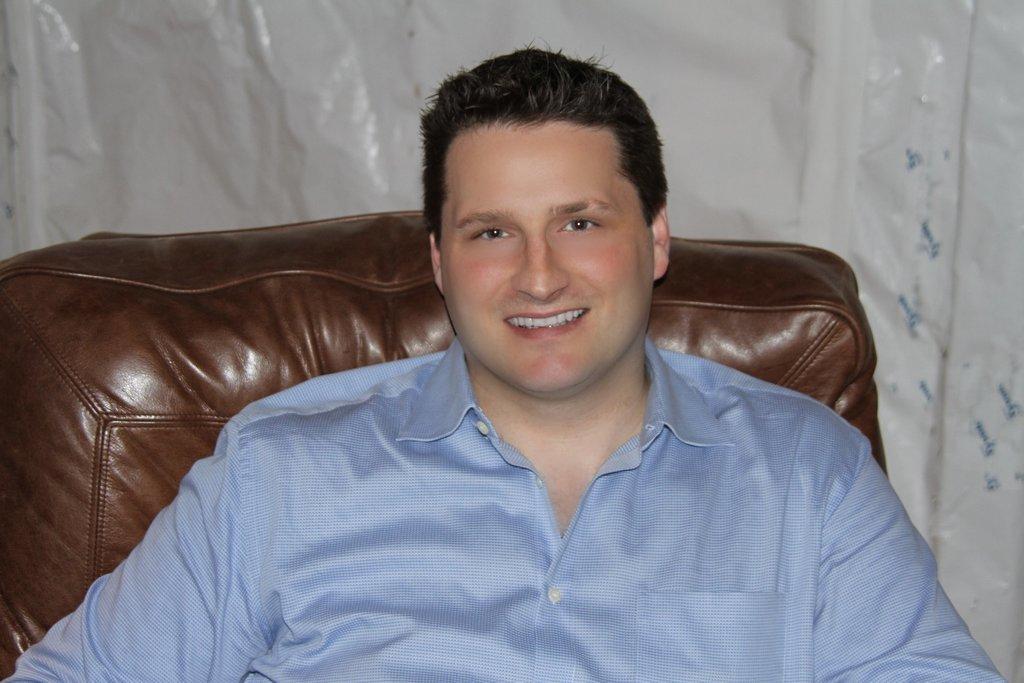Can you describe this image briefly? In the foreground of the picture we can see a person sitting in a couch. In the background there is a white color object. 